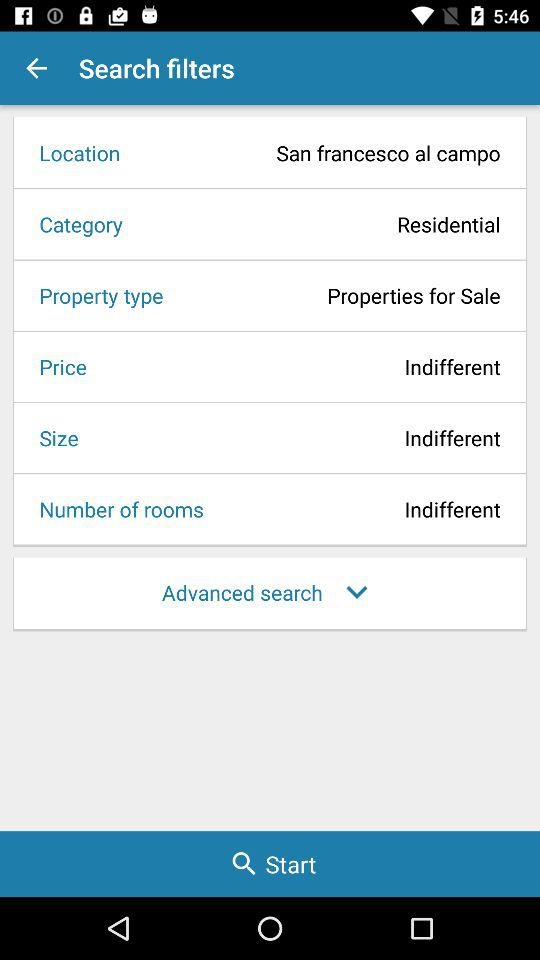What is the location? The location is San Francesco al Campo. 